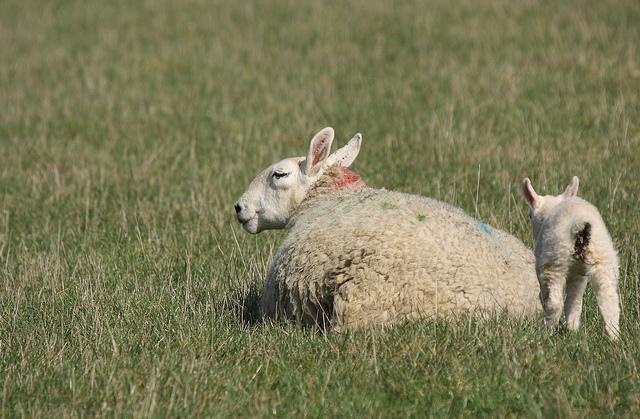How many total ears are there in this picture?
Give a very brief answer. 4. How many sheep can be seen?
Give a very brief answer. 2. How many cats are here?
Give a very brief answer. 0. 